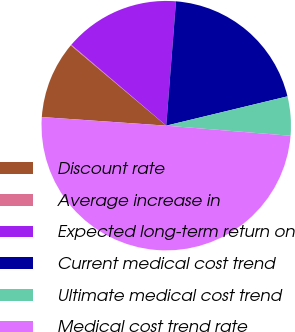<chart> <loc_0><loc_0><loc_500><loc_500><pie_chart><fcel>Discount rate<fcel>Average increase in<fcel>Expected long-term return on<fcel>Current medical cost trend<fcel>Ultimate medical cost trend<fcel>Medical cost trend rate<nl><fcel>10.04%<fcel>0.1%<fcel>15.01%<fcel>19.98%<fcel>5.07%<fcel>49.8%<nl></chart> 